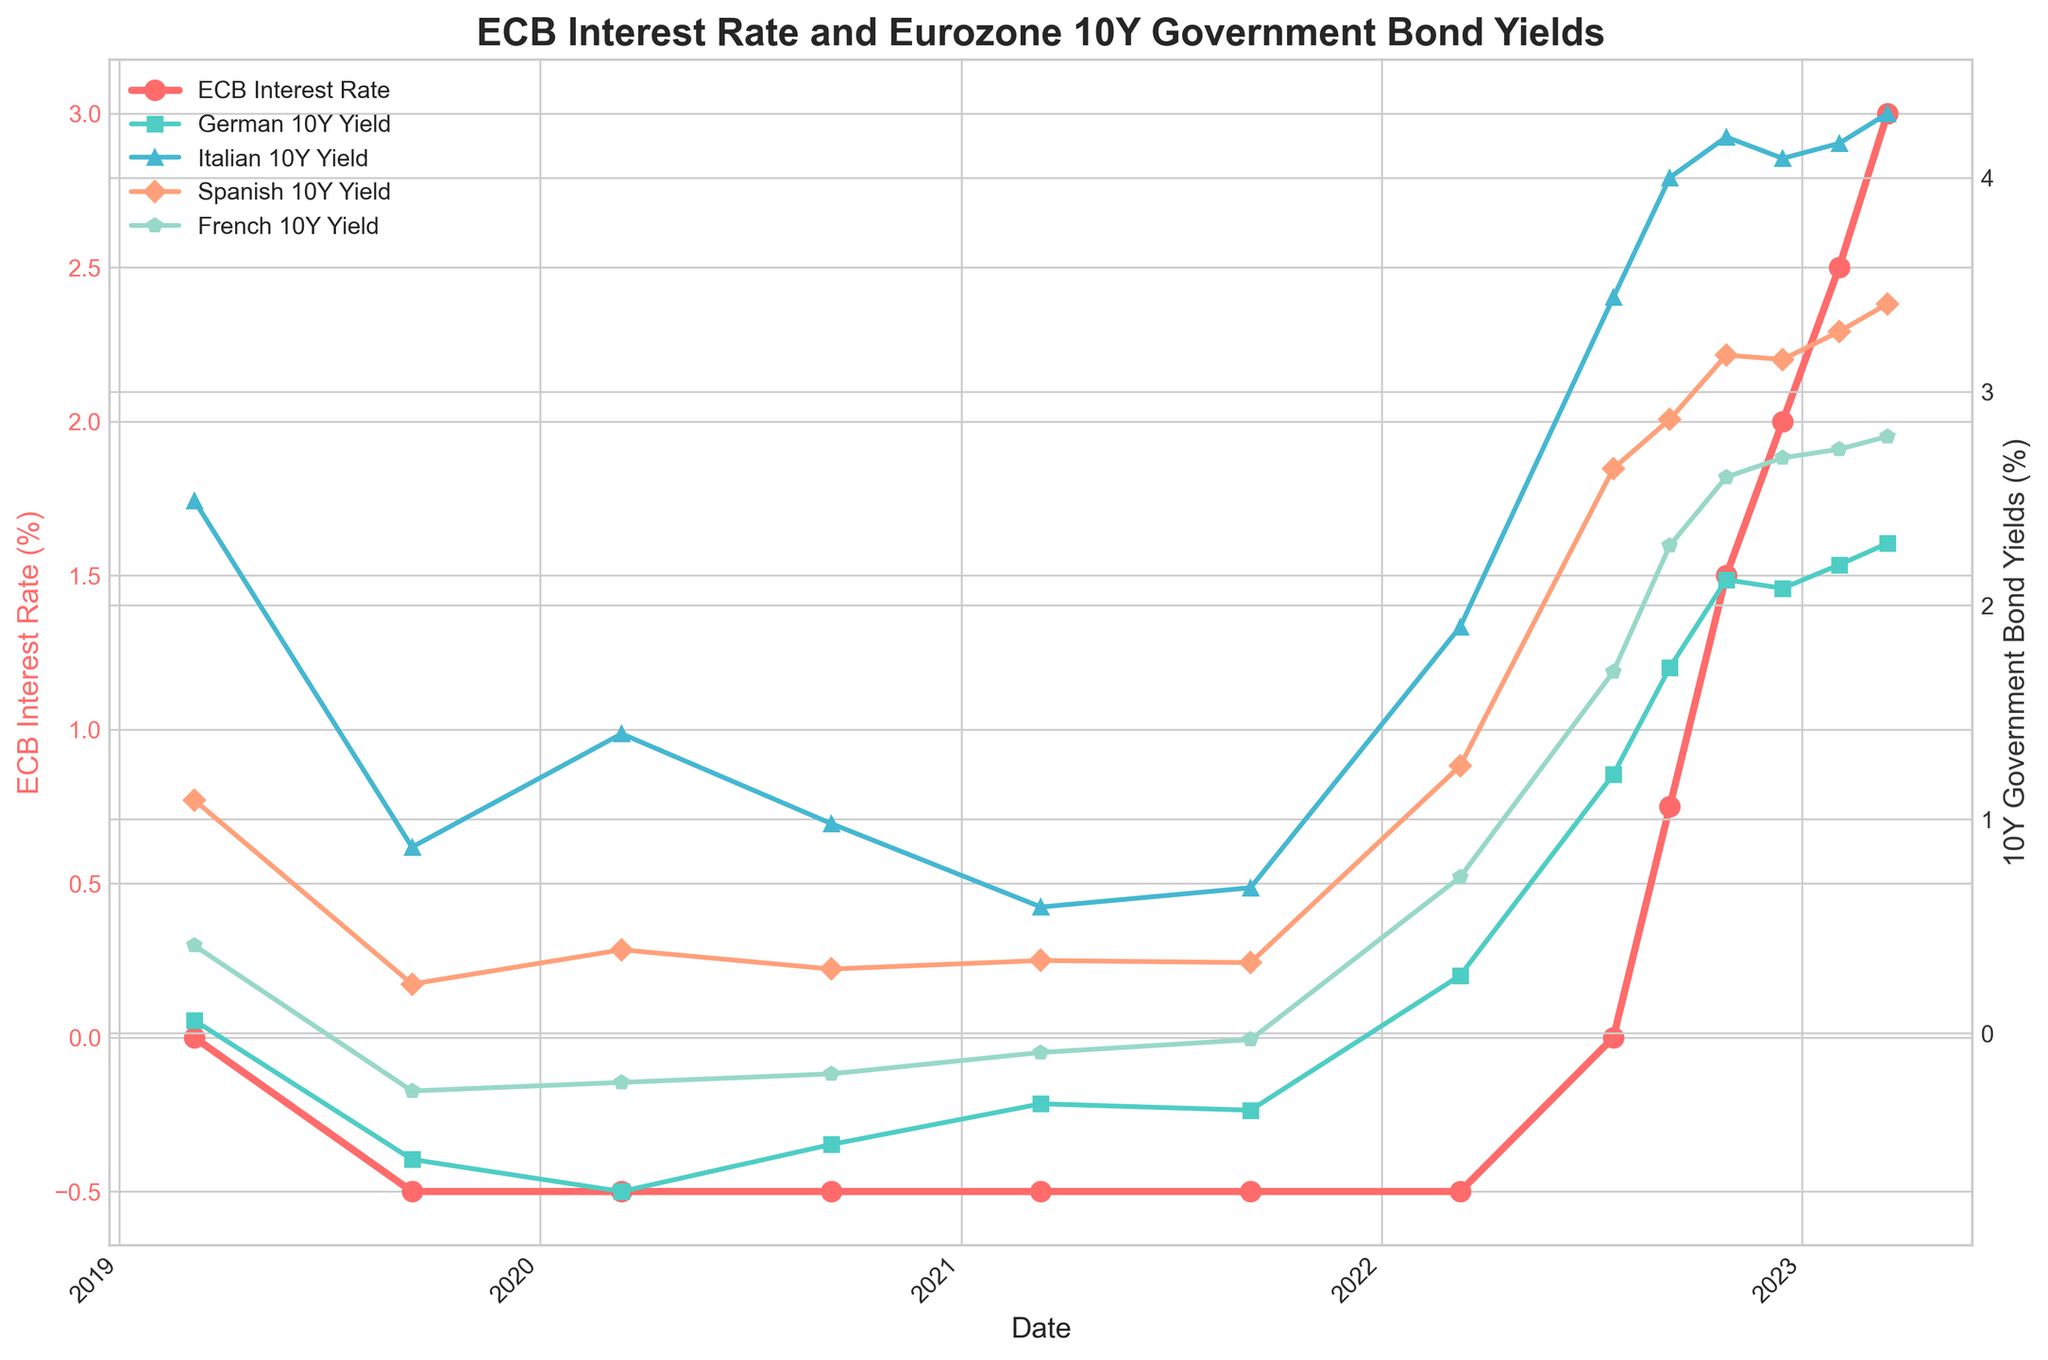What were the ECB interest rates in 2019 and 2023? The ECB interest rate in 2019 was shown on two dates: March 7th and September 12th. On March 7th, it was 0.00%, and on September 12th, it dropped to -0.50%. In 2023, the rates displayed were on two dates: February 2nd and March 16th. On February 2nd, it was 2.50%, and on March 16th, it increased to 3.00%.
Answer: 0.00%, -0.50% in 2019 and 2.50%, 3.00% in 2023 Which country's 10-year government bond yield showed the most significant increase from March 2020 to March 2023? By comparing the bond yields from March 2020 (March 12, 2020) to March 2023 (March 16, 2023), the increase can be calculated for each country. Germany went from -0.74% to 2.29% (3.03% increase), Italy from 1.40% to 4.30% (2.90% increase), Spain from 0.39% to 3.41% (3.02% increase), and France from -0.23% to 2.79% (3.02% increase). Thus, Germany showed the most significant increase.
Answer: Germany How did the French 10-year bond yield change between December 2022 and March 2023? The French 10-year bond yield in December 2022 (December 15th) was 2.69%. By March 2023 (March 16th), it had risen to 2.79%. The change can be calculated as 2.79% - 2.69% = 0.10%.
Answer: Increased by 0.10% What is the relationship between the ECB interest rate and the Italian 10Y yield from March 2022 to December 2022? From March 2022 to December 2022, the ECB interest rate increased from -0.50% to 2.00%. The Italian 10Y yield also increased from 1.90% to 4.09%, showing a positive correlation in this period. As the ECB interest rate rose, the Italian 10Y yield also went up.
Answer: Positive correlation Compare the German 10Y yield and Spanish 10Y Yield on July 21, 2022. On July 21, 2022, the German 10Y yield was 1.21%, while the Spanish 10Y yield was 2.64%. By comparing these, the Spanish yield was higher than the German yield by 2.64% - 1.21% = 1.43%.
Answer: Spanish 10Y yield was higher by 1.43% What was the trend in the ECB interest rate and bond yields from 2019 to 2023? From 2019 to 2023, the ECB interest rate initially dropped to -0.50% in 2019 and remained there until mid-2022, when it started rising and reached 3.00% by March 2023. Correspondingly, the bond yields generally fell during the low interest rate period and began to increase significantly as the ECB interest rate started to rise in 2022.
Answer: ECB rate decreased first, then increased; bond yields rose with rate increases Which bond had the highest yield in March 2023 among German, Italian, Spanish, and French bonds? By examining the yields in March 2023 (March 16, 2023), the values were: German 2.29%, Italian 4.30%, Spanish 3.41%, and French 2.79%. The Italian 10Y yield was the highest at 4.30%.
Answer: Italian bond How did the ECB interest rate change impact the German 10Y yield between March 2022 and July 2022? On March 10, 2022, the ECB interest rate was -0.50%, and the German 10Y yield was 0.27%. On July 21, 2022, the ECB interest rate increased to 0.00%, and the German 10Y yield went up to 1.21%. The ECB rate increased by 0.50%, and the German 10Y yield increased by 0.94%.
Answer: The yield increased by 0.94% with a rate hike of 0.50% What color represents the Spanish 10Y Yield in the figure? In the figure, the Spanish 10Y Yield is represented with a line colored in an orange shade and marked by diamond-shaped points.
Answer: Orange 